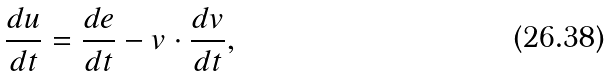<formula> <loc_0><loc_0><loc_500><loc_500>\frac { d u } { d t } = \frac { d e } { d t } - { v } \cdot \frac { d { v } } { d t } ,</formula> 